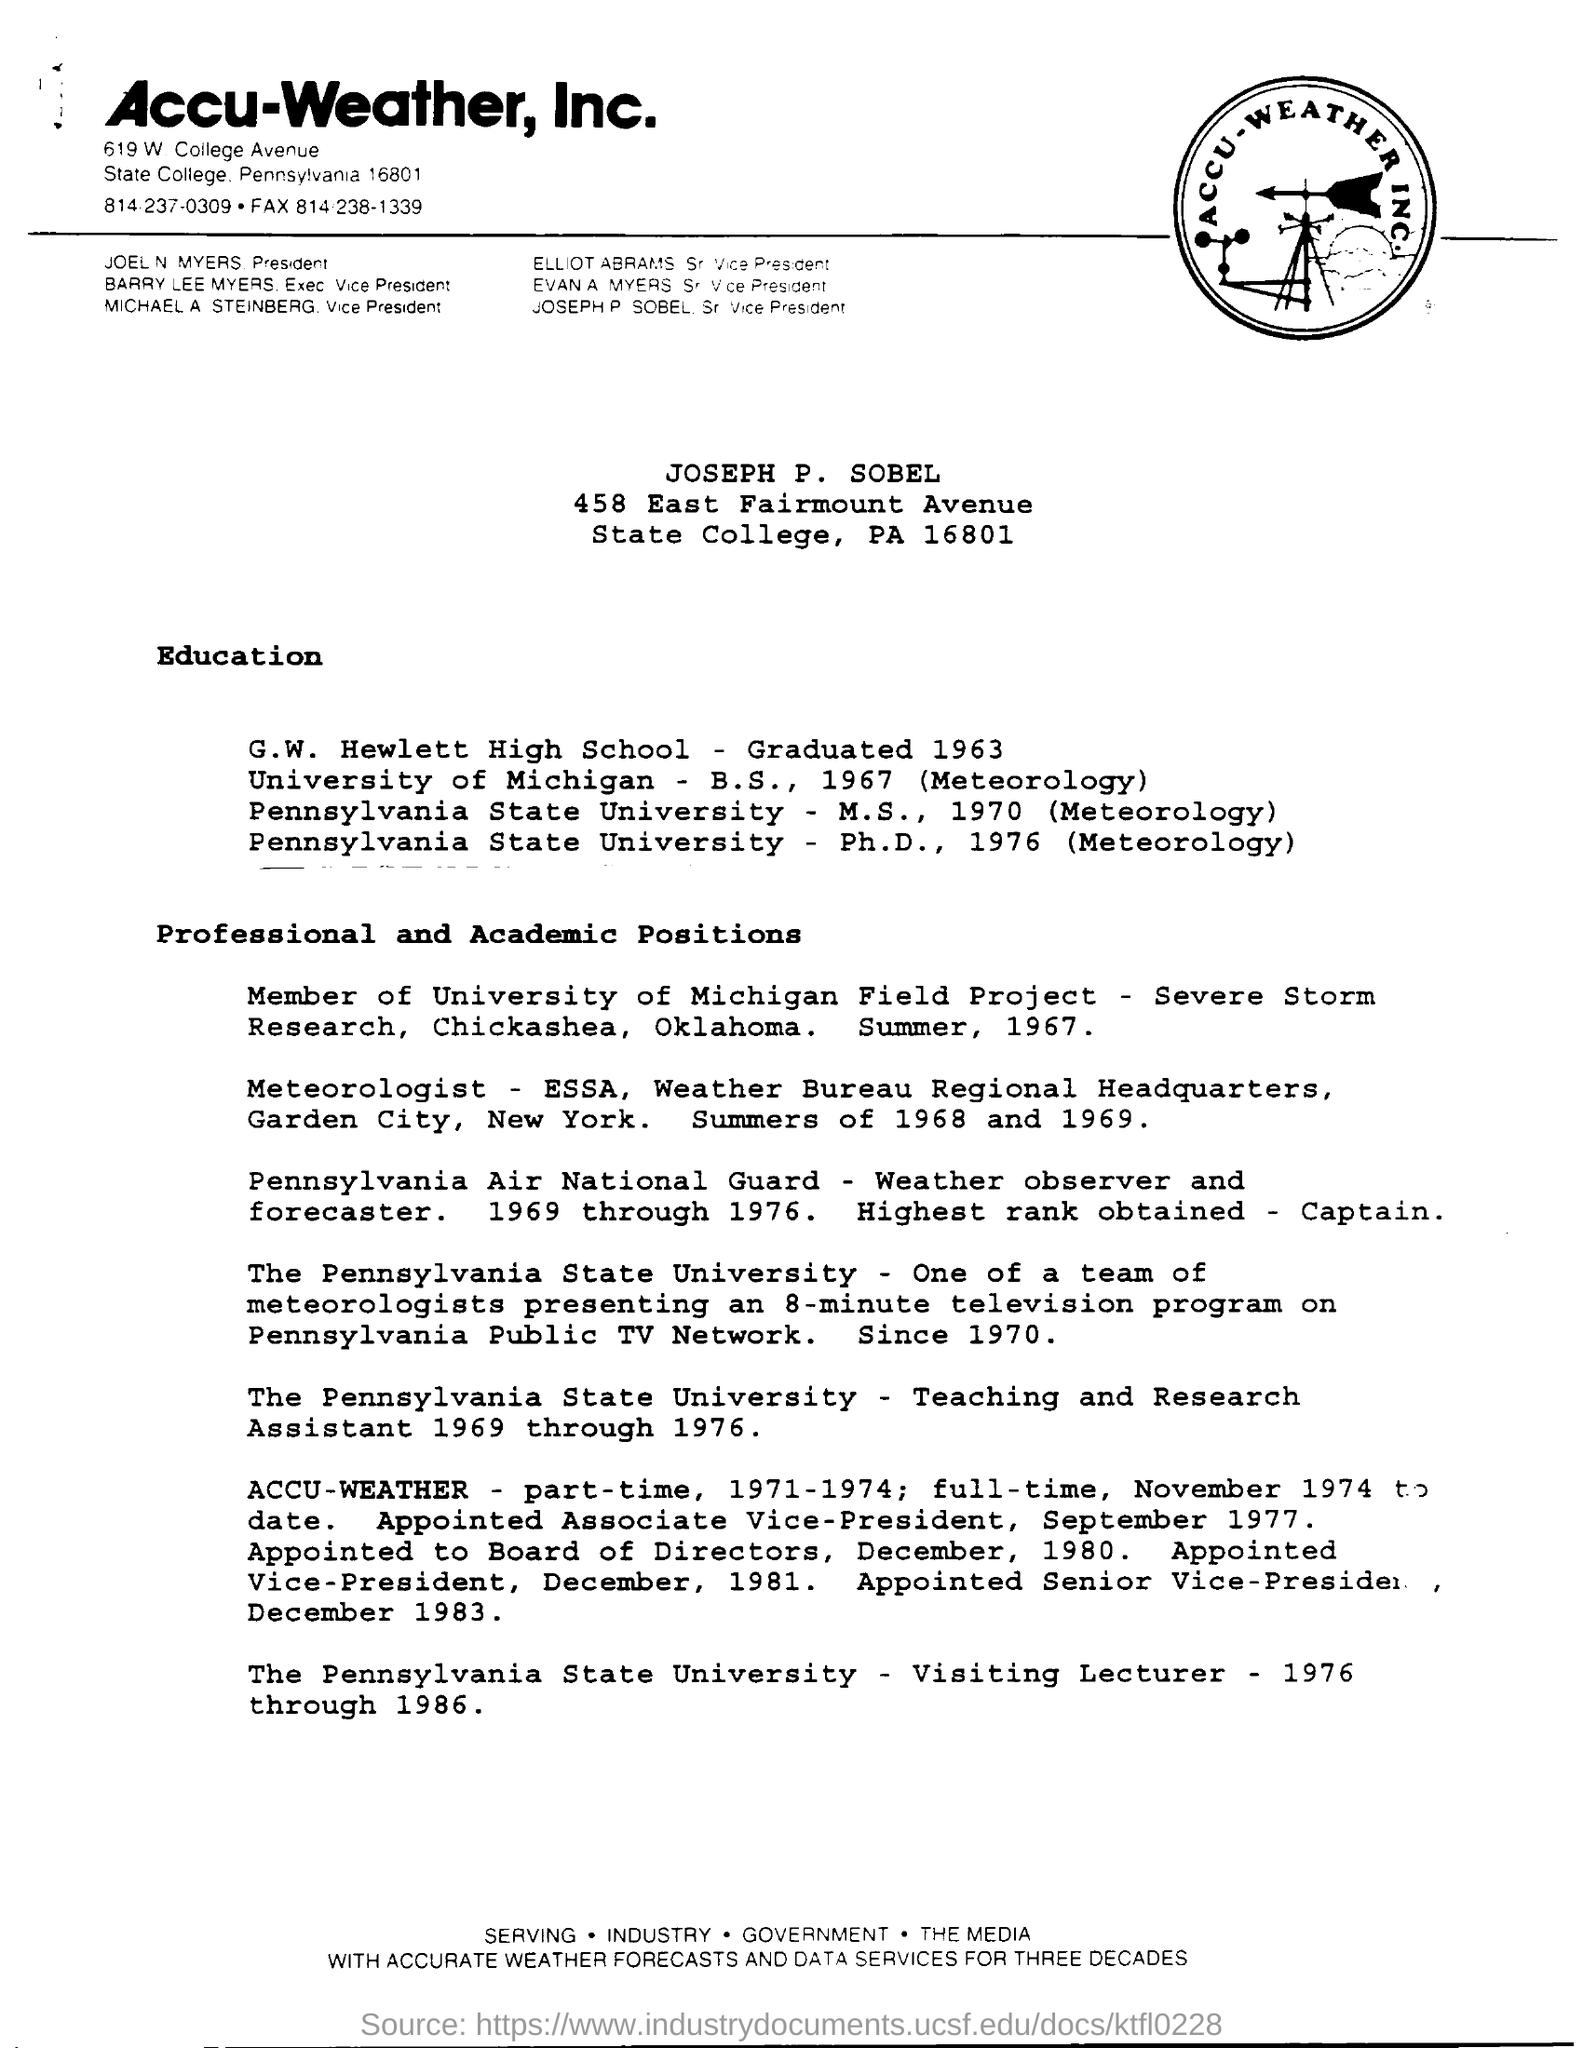Which firm is mentioned at the top of the page?
Ensure brevity in your answer.  Accu-Weather, Inc. Who is the President?
Offer a terse response. JOEL N MYERS. Which year did JOSEPH graduate from G.W. Hewlett High School?
Provide a succinct answer. 1963. 